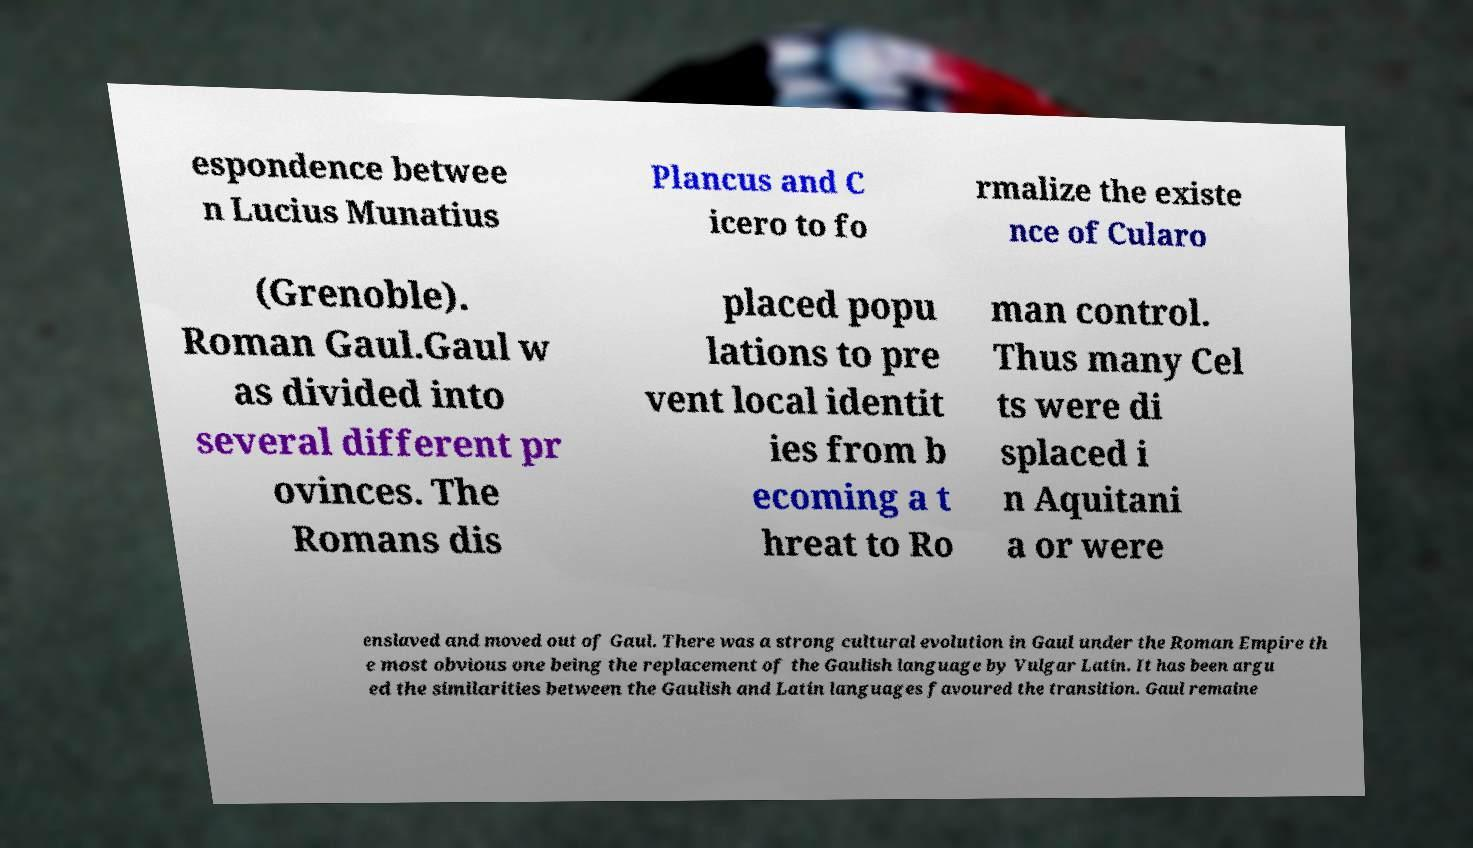Please identify and transcribe the text found in this image. espondence betwee n Lucius Munatius Plancus and C icero to fo rmalize the existe nce of Cularo (Grenoble). Roman Gaul.Gaul w as divided into several different pr ovinces. The Romans dis placed popu lations to pre vent local identit ies from b ecoming a t hreat to Ro man control. Thus many Cel ts were di splaced i n Aquitani a or were enslaved and moved out of Gaul. There was a strong cultural evolution in Gaul under the Roman Empire th e most obvious one being the replacement of the Gaulish language by Vulgar Latin. It has been argu ed the similarities between the Gaulish and Latin languages favoured the transition. Gaul remaine 